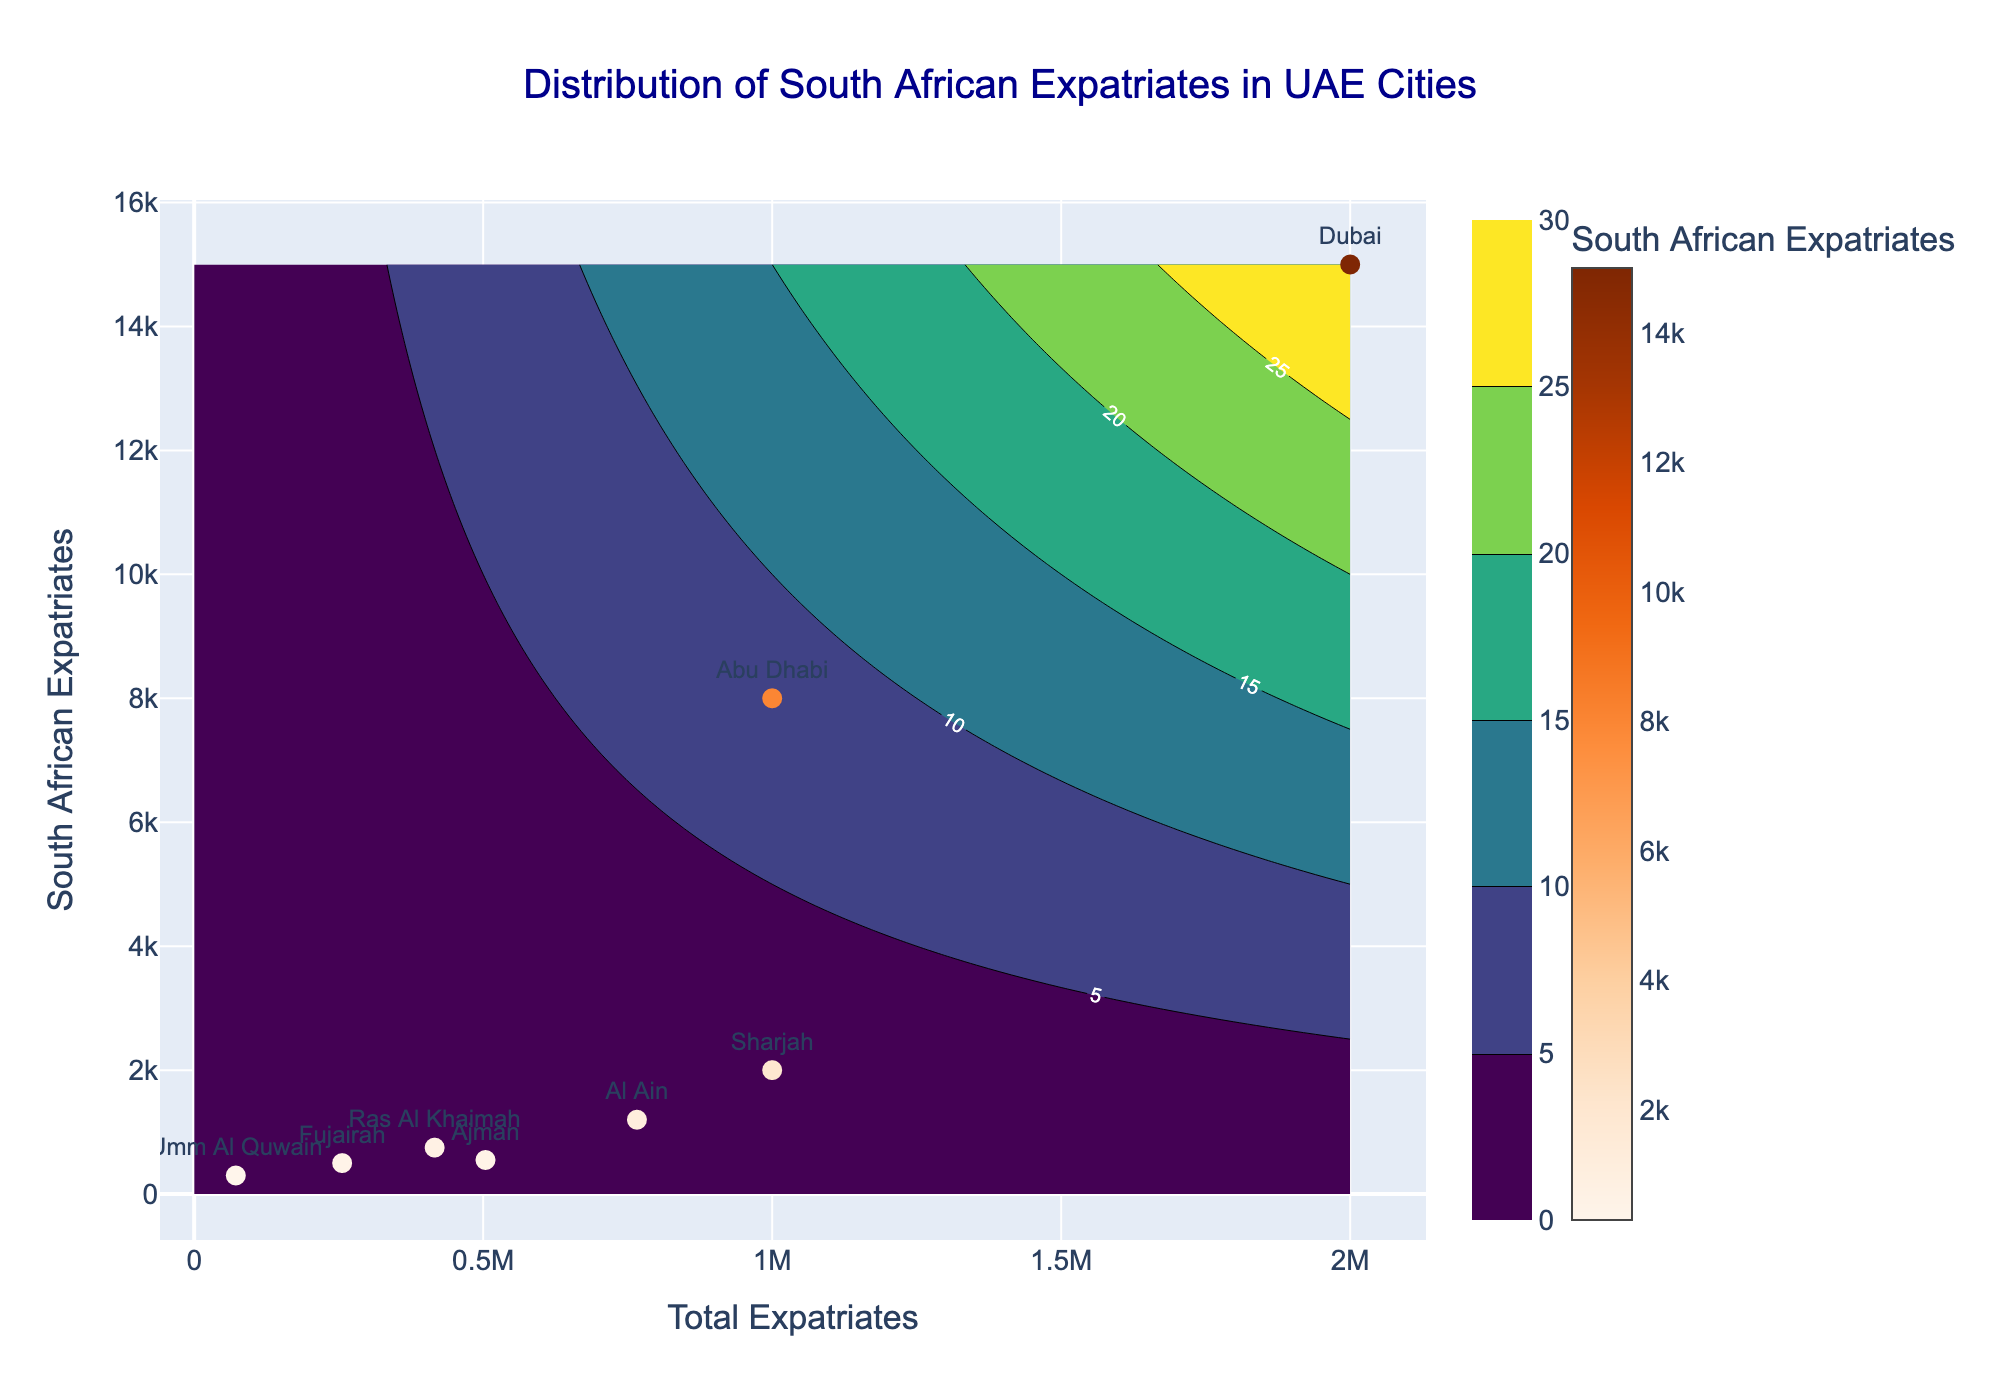What is the title of the plot? The title is located at the top center of the plot. It reads "Distribution of South African Expatriates in UAE Cities".
Answer: Distribution of South African Expatriates in UAE Cities Which city has the highest number of South African expatriates? The city labels are given next to the data points on the scatter plot. The highest number of South African expatriates is shown to be in Dubai.
Answer: Dubai How many South African expatriates are there in Abu Dhabi compared to Al Ain? Refer to the y-axis values for the South African expatriates for each city. Abu Dhabi has 8,000 and Al Ain has 1,200, so the difference is 8,000 - 1,200.
Answer: 6,800 Which city has the lowest density of South African expatriates according to the plot? Observe the scatter plot points and their respective y-axis values. Umm Al Quwain has the lowest, with 300 South African expatriates. Density usually refers to total numbers, not area.
Answer: Umm Al Quwain How are the Total Expatriates represented in the plot? The x-axis represents the Total Expatriates for each city. Each point on the plot is placed according to the respective Total Expatriates number.
Answer: By the x-axis Which city has a similar number of Total Expatriates but fewer South African expatriates compared to Sharjah? Sharjah has 1,000,000 Total Expatriates and 2,000 South African expatriates. Fujairah has similar total expatriates (256,000) but fewer South African expatriates (500).
Answer: Fujairah Which contour color indicates higher density regions on the plot? The contour colors range from dark to light on the Viridis colormap. Lighter colors typically indicate higher density.
Answer: Lighter colors How does the number of South African expatriates correlate with Total Expatriates in Dubai and Abu Dhabi? Both cities have high Total Expatriates, with Dubai having 2,000,000 and Abu Dhabi having 1,000,000. Dubai also has more South African expatriates than Abu Dhabi. Generally, a positive correlation is observed.
Answer: Positive correlation What is the general distribution trend of South African expatriates across the Total Expatriates in UAE cities? By observing the scatter plot, more South African expatriates generally live in cities with a higher number of Total Expatriates.
Answer: Higher numbers in cities with more Total Expatriates 